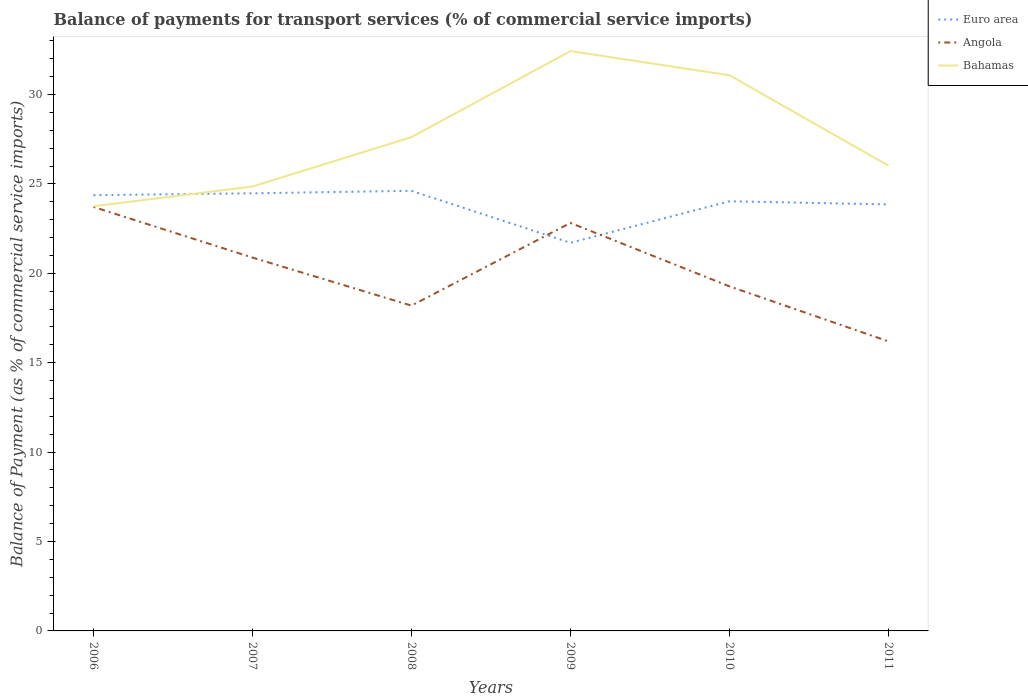How many different coloured lines are there?
Offer a very short reply. 3. Across all years, what is the maximum balance of payments for transport services in Bahamas?
Your response must be concise. 23.75. In which year was the balance of payments for transport services in Euro area maximum?
Provide a succinct answer. 2009. What is the total balance of payments for transport services in Angola in the graph?
Offer a terse response. 2.83. What is the difference between the highest and the second highest balance of payments for transport services in Bahamas?
Make the answer very short. 8.68. What is the difference between the highest and the lowest balance of payments for transport services in Bahamas?
Keep it short and to the point. 2. Is the balance of payments for transport services in Angola strictly greater than the balance of payments for transport services in Euro area over the years?
Your response must be concise. No. What is the difference between two consecutive major ticks on the Y-axis?
Your response must be concise. 5. Are the values on the major ticks of Y-axis written in scientific E-notation?
Make the answer very short. No. Does the graph contain grids?
Ensure brevity in your answer.  No. What is the title of the graph?
Provide a short and direct response. Balance of payments for transport services (% of commercial service imports). What is the label or title of the Y-axis?
Ensure brevity in your answer.  Balance of Payment (as % of commercial service imports). What is the Balance of Payment (as % of commercial service imports) in Euro area in 2006?
Make the answer very short. 24.37. What is the Balance of Payment (as % of commercial service imports) of Angola in 2006?
Your response must be concise. 23.71. What is the Balance of Payment (as % of commercial service imports) in Bahamas in 2006?
Your response must be concise. 23.75. What is the Balance of Payment (as % of commercial service imports) of Euro area in 2007?
Your answer should be compact. 24.47. What is the Balance of Payment (as % of commercial service imports) in Angola in 2007?
Provide a succinct answer. 20.88. What is the Balance of Payment (as % of commercial service imports) of Bahamas in 2007?
Give a very brief answer. 24.85. What is the Balance of Payment (as % of commercial service imports) of Euro area in 2008?
Keep it short and to the point. 24.61. What is the Balance of Payment (as % of commercial service imports) of Angola in 2008?
Your answer should be very brief. 18.19. What is the Balance of Payment (as % of commercial service imports) in Bahamas in 2008?
Provide a succinct answer. 27.62. What is the Balance of Payment (as % of commercial service imports) of Euro area in 2009?
Provide a succinct answer. 21.71. What is the Balance of Payment (as % of commercial service imports) in Angola in 2009?
Provide a short and direct response. 22.82. What is the Balance of Payment (as % of commercial service imports) in Bahamas in 2009?
Make the answer very short. 32.43. What is the Balance of Payment (as % of commercial service imports) of Euro area in 2010?
Ensure brevity in your answer.  24.03. What is the Balance of Payment (as % of commercial service imports) in Angola in 2010?
Your answer should be very brief. 19.27. What is the Balance of Payment (as % of commercial service imports) in Bahamas in 2010?
Offer a terse response. 31.08. What is the Balance of Payment (as % of commercial service imports) in Euro area in 2011?
Give a very brief answer. 23.85. What is the Balance of Payment (as % of commercial service imports) of Angola in 2011?
Your response must be concise. 16.19. What is the Balance of Payment (as % of commercial service imports) in Bahamas in 2011?
Ensure brevity in your answer.  26.02. Across all years, what is the maximum Balance of Payment (as % of commercial service imports) of Euro area?
Keep it short and to the point. 24.61. Across all years, what is the maximum Balance of Payment (as % of commercial service imports) of Angola?
Offer a terse response. 23.71. Across all years, what is the maximum Balance of Payment (as % of commercial service imports) of Bahamas?
Make the answer very short. 32.43. Across all years, what is the minimum Balance of Payment (as % of commercial service imports) of Euro area?
Your response must be concise. 21.71. Across all years, what is the minimum Balance of Payment (as % of commercial service imports) of Angola?
Ensure brevity in your answer.  16.19. Across all years, what is the minimum Balance of Payment (as % of commercial service imports) of Bahamas?
Your answer should be very brief. 23.75. What is the total Balance of Payment (as % of commercial service imports) of Euro area in the graph?
Your answer should be compact. 143.05. What is the total Balance of Payment (as % of commercial service imports) of Angola in the graph?
Provide a short and direct response. 121.07. What is the total Balance of Payment (as % of commercial service imports) of Bahamas in the graph?
Your answer should be very brief. 165.75. What is the difference between the Balance of Payment (as % of commercial service imports) in Euro area in 2006 and that in 2007?
Offer a very short reply. -0.1. What is the difference between the Balance of Payment (as % of commercial service imports) in Angola in 2006 and that in 2007?
Your response must be concise. 2.83. What is the difference between the Balance of Payment (as % of commercial service imports) in Bahamas in 2006 and that in 2007?
Provide a short and direct response. -1.1. What is the difference between the Balance of Payment (as % of commercial service imports) in Euro area in 2006 and that in 2008?
Offer a very short reply. -0.24. What is the difference between the Balance of Payment (as % of commercial service imports) of Angola in 2006 and that in 2008?
Offer a very short reply. 5.52. What is the difference between the Balance of Payment (as % of commercial service imports) of Bahamas in 2006 and that in 2008?
Your answer should be very brief. -3.87. What is the difference between the Balance of Payment (as % of commercial service imports) of Euro area in 2006 and that in 2009?
Your response must be concise. 2.67. What is the difference between the Balance of Payment (as % of commercial service imports) of Angola in 2006 and that in 2009?
Your answer should be very brief. 0.89. What is the difference between the Balance of Payment (as % of commercial service imports) in Bahamas in 2006 and that in 2009?
Your answer should be compact. -8.68. What is the difference between the Balance of Payment (as % of commercial service imports) of Euro area in 2006 and that in 2010?
Your answer should be very brief. 0.34. What is the difference between the Balance of Payment (as % of commercial service imports) of Angola in 2006 and that in 2010?
Provide a short and direct response. 4.44. What is the difference between the Balance of Payment (as % of commercial service imports) of Bahamas in 2006 and that in 2010?
Keep it short and to the point. -7.33. What is the difference between the Balance of Payment (as % of commercial service imports) of Euro area in 2006 and that in 2011?
Your answer should be very brief. 0.52. What is the difference between the Balance of Payment (as % of commercial service imports) in Angola in 2006 and that in 2011?
Make the answer very short. 7.52. What is the difference between the Balance of Payment (as % of commercial service imports) of Bahamas in 2006 and that in 2011?
Ensure brevity in your answer.  -2.27. What is the difference between the Balance of Payment (as % of commercial service imports) of Euro area in 2007 and that in 2008?
Make the answer very short. -0.14. What is the difference between the Balance of Payment (as % of commercial service imports) in Angola in 2007 and that in 2008?
Your answer should be very brief. 2.69. What is the difference between the Balance of Payment (as % of commercial service imports) of Bahamas in 2007 and that in 2008?
Your answer should be very brief. -2.76. What is the difference between the Balance of Payment (as % of commercial service imports) in Euro area in 2007 and that in 2009?
Your answer should be very brief. 2.77. What is the difference between the Balance of Payment (as % of commercial service imports) of Angola in 2007 and that in 2009?
Your answer should be compact. -1.94. What is the difference between the Balance of Payment (as % of commercial service imports) of Bahamas in 2007 and that in 2009?
Give a very brief answer. -7.57. What is the difference between the Balance of Payment (as % of commercial service imports) of Euro area in 2007 and that in 2010?
Give a very brief answer. 0.45. What is the difference between the Balance of Payment (as % of commercial service imports) in Angola in 2007 and that in 2010?
Ensure brevity in your answer.  1.61. What is the difference between the Balance of Payment (as % of commercial service imports) of Bahamas in 2007 and that in 2010?
Your answer should be very brief. -6.22. What is the difference between the Balance of Payment (as % of commercial service imports) in Euro area in 2007 and that in 2011?
Your answer should be very brief. 0.62. What is the difference between the Balance of Payment (as % of commercial service imports) in Angola in 2007 and that in 2011?
Keep it short and to the point. 4.69. What is the difference between the Balance of Payment (as % of commercial service imports) of Bahamas in 2007 and that in 2011?
Your response must be concise. -1.17. What is the difference between the Balance of Payment (as % of commercial service imports) of Euro area in 2008 and that in 2009?
Your answer should be compact. 2.91. What is the difference between the Balance of Payment (as % of commercial service imports) of Angola in 2008 and that in 2009?
Provide a short and direct response. -4.63. What is the difference between the Balance of Payment (as % of commercial service imports) in Bahamas in 2008 and that in 2009?
Your response must be concise. -4.81. What is the difference between the Balance of Payment (as % of commercial service imports) in Euro area in 2008 and that in 2010?
Offer a terse response. 0.58. What is the difference between the Balance of Payment (as % of commercial service imports) of Angola in 2008 and that in 2010?
Ensure brevity in your answer.  -1.08. What is the difference between the Balance of Payment (as % of commercial service imports) of Bahamas in 2008 and that in 2010?
Make the answer very short. -3.46. What is the difference between the Balance of Payment (as % of commercial service imports) in Euro area in 2008 and that in 2011?
Ensure brevity in your answer.  0.76. What is the difference between the Balance of Payment (as % of commercial service imports) of Angola in 2008 and that in 2011?
Ensure brevity in your answer.  2. What is the difference between the Balance of Payment (as % of commercial service imports) in Bahamas in 2008 and that in 2011?
Your answer should be very brief. 1.6. What is the difference between the Balance of Payment (as % of commercial service imports) of Euro area in 2009 and that in 2010?
Provide a succinct answer. -2.32. What is the difference between the Balance of Payment (as % of commercial service imports) of Angola in 2009 and that in 2010?
Offer a terse response. 3.55. What is the difference between the Balance of Payment (as % of commercial service imports) of Bahamas in 2009 and that in 2010?
Your answer should be very brief. 1.35. What is the difference between the Balance of Payment (as % of commercial service imports) in Euro area in 2009 and that in 2011?
Make the answer very short. -2.15. What is the difference between the Balance of Payment (as % of commercial service imports) in Angola in 2009 and that in 2011?
Provide a succinct answer. 6.63. What is the difference between the Balance of Payment (as % of commercial service imports) in Bahamas in 2009 and that in 2011?
Provide a succinct answer. 6.41. What is the difference between the Balance of Payment (as % of commercial service imports) of Euro area in 2010 and that in 2011?
Your answer should be very brief. 0.18. What is the difference between the Balance of Payment (as % of commercial service imports) in Angola in 2010 and that in 2011?
Offer a very short reply. 3.08. What is the difference between the Balance of Payment (as % of commercial service imports) in Bahamas in 2010 and that in 2011?
Provide a short and direct response. 5.06. What is the difference between the Balance of Payment (as % of commercial service imports) in Euro area in 2006 and the Balance of Payment (as % of commercial service imports) in Angola in 2007?
Ensure brevity in your answer.  3.49. What is the difference between the Balance of Payment (as % of commercial service imports) in Euro area in 2006 and the Balance of Payment (as % of commercial service imports) in Bahamas in 2007?
Offer a very short reply. -0.48. What is the difference between the Balance of Payment (as % of commercial service imports) in Angola in 2006 and the Balance of Payment (as % of commercial service imports) in Bahamas in 2007?
Ensure brevity in your answer.  -1.14. What is the difference between the Balance of Payment (as % of commercial service imports) of Euro area in 2006 and the Balance of Payment (as % of commercial service imports) of Angola in 2008?
Your response must be concise. 6.18. What is the difference between the Balance of Payment (as % of commercial service imports) of Euro area in 2006 and the Balance of Payment (as % of commercial service imports) of Bahamas in 2008?
Your response must be concise. -3.25. What is the difference between the Balance of Payment (as % of commercial service imports) in Angola in 2006 and the Balance of Payment (as % of commercial service imports) in Bahamas in 2008?
Make the answer very short. -3.9. What is the difference between the Balance of Payment (as % of commercial service imports) of Euro area in 2006 and the Balance of Payment (as % of commercial service imports) of Angola in 2009?
Make the answer very short. 1.55. What is the difference between the Balance of Payment (as % of commercial service imports) of Euro area in 2006 and the Balance of Payment (as % of commercial service imports) of Bahamas in 2009?
Make the answer very short. -8.06. What is the difference between the Balance of Payment (as % of commercial service imports) of Angola in 2006 and the Balance of Payment (as % of commercial service imports) of Bahamas in 2009?
Ensure brevity in your answer.  -8.71. What is the difference between the Balance of Payment (as % of commercial service imports) of Euro area in 2006 and the Balance of Payment (as % of commercial service imports) of Angola in 2010?
Offer a terse response. 5.1. What is the difference between the Balance of Payment (as % of commercial service imports) of Euro area in 2006 and the Balance of Payment (as % of commercial service imports) of Bahamas in 2010?
Ensure brevity in your answer.  -6.71. What is the difference between the Balance of Payment (as % of commercial service imports) in Angola in 2006 and the Balance of Payment (as % of commercial service imports) in Bahamas in 2010?
Offer a very short reply. -7.36. What is the difference between the Balance of Payment (as % of commercial service imports) in Euro area in 2006 and the Balance of Payment (as % of commercial service imports) in Angola in 2011?
Ensure brevity in your answer.  8.18. What is the difference between the Balance of Payment (as % of commercial service imports) of Euro area in 2006 and the Balance of Payment (as % of commercial service imports) of Bahamas in 2011?
Your answer should be very brief. -1.65. What is the difference between the Balance of Payment (as % of commercial service imports) of Angola in 2006 and the Balance of Payment (as % of commercial service imports) of Bahamas in 2011?
Keep it short and to the point. -2.31. What is the difference between the Balance of Payment (as % of commercial service imports) of Euro area in 2007 and the Balance of Payment (as % of commercial service imports) of Angola in 2008?
Your response must be concise. 6.28. What is the difference between the Balance of Payment (as % of commercial service imports) in Euro area in 2007 and the Balance of Payment (as % of commercial service imports) in Bahamas in 2008?
Make the answer very short. -3.14. What is the difference between the Balance of Payment (as % of commercial service imports) in Angola in 2007 and the Balance of Payment (as % of commercial service imports) in Bahamas in 2008?
Provide a short and direct response. -6.74. What is the difference between the Balance of Payment (as % of commercial service imports) of Euro area in 2007 and the Balance of Payment (as % of commercial service imports) of Angola in 2009?
Provide a short and direct response. 1.66. What is the difference between the Balance of Payment (as % of commercial service imports) in Euro area in 2007 and the Balance of Payment (as % of commercial service imports) in Bahamas in 2009?
Make the answer very short. -7.95. What is the difference between the Balance of Payment (as % of commercial service imports) in Angola in 2007 and the Balance of Payment (as % of commercial service imports) in Bahamas in 2009?
Your answer should be compact. -11.55. What is the difference between the Balance of Payment (as % of commercial service imports) in Euro area in 2007 and the Balance of Payment (as % of commercial service imports) in Angola in 2010?
Keep it short and to the point. 5.2. What is the difference between the Balance of Payment (as % of commercial service imports) of Euro area in 2007 and the Balance of Payment (as % of commercial service imports) of Bahamas in 2010?
Offer a terse response. -6.6. What is the difference between the Balance of Payment (as % of commercial service imports) in Angola in 2007 and the Balance of Payment (as % of commercial service imports) in Bahamas in 2010?
Keep it short and to the point. -10.2. What is the difference between the Balance of Payment (as % of commercial service imports) of Euro area in 2007 and the Balance of Payment (as % of commercial service imports) of Angola in 2011?
Your answer should be very brief. 8.28. What is the difference between the Balance of Payment (as % of commercial service imports) of Euro area in 2007 and the Balance of Payment (as % of commercial service imports) of Bahamas in 2011?
Give a very brief answer. -1.55. What is the difference between the Balance of Payment (as % of commercial service imports) of Angola in 2007 and the Balance of Payment (as % of commercial service imports) of Bahamas in 2011?
Your response must be concise. -5.14. What is the difference between the Balance of Payment (as % of commercial service imports) in Euro area in 2008 and the Balance of Payment (as % of commercial service imports) in Angola in 2009?
Your response must be concise. 1.79. What is the difference between the Balance of Payment (as % of commercial service imports) of Euro area in 2008 and the Balance of Payment (as % of commercial service imports) of Bahamas in 2009?
Make the answer very short. -7.81. What is the difference between the Balance of Payment (as % of commercial service imports) in Angola in 2008 and the Balance of Payment (as % of commercial service imports) in Bahamas in 2009?
Offer a terse response. -14.23. What is the difference between the Balance of Payment (as % of commercial service imports) of Euro area in 2008 and the Balance of Payment (as % of commercial service imports) of Angola in 2010?
Ensure brevity in your answer.  5.34. What is the difference between the Balance of Payment (as % of commercial service imports) of Euro area in 2008 and the Balance of Payment (as % of commercial service imports) of Bahamas in 2010?
Offer a terse response. -6.46. What is the difference between the Balance of Payment (as % of commercial service imports) in Angola in 2008 and the Balance of Payment (as % of commercial service imports) in Bahamas in 2010?
Your answer should be very brief. -12.88. What is the difference between the Balance of Payment (as % of commercial service imports) of Euro area in 2008 and the Balance of Payment (as % of commercial service imports) of Angola in 2011?
Your answer should be very brief. 8.42. What is the difference between the Balance of Payment (as % of commercial service imports) in Euro area in 2008 and the Balance of Payment (as % of commercial service imports) in Bahamas in 2011?
Provide a short and direct response. -1.41. What is the difference between the Balance of Payment (as % of commercial service imports) of Angola in 2008 and the Balance of Payment (as % of commercial service imports) of Bahamas in 2011?
Give a very brief answer. -7.83. What is the difference between the Balance of Payment (as % of commercial service imports) in Euro area in 2009 and the Balance of Payment (as % of commercial service imports) in Angola in 2010?
Your answer should be very brief. 2.44. What is the difference between the Balance of Payment (as % of commercial service imports) in Euro area in 2009 and the Balance of Payment (as % of commercial service imports) in Bahamas in 2010?
Offer a very short reply. -9.37. What is the difference between the Balance of Payment (as % of commercial service imports) of Angola in 2009 and the Balance of Payment (as % of commercial service imports) of Bahamas in 2010?
Offer a terse response. -8.26. What is the difference between the Balance of Payment (as % of commercial service imports) of Euro area in 2009 and the Balance of Payment (as % of commercial service imports) of Angola in 2011?
Give a very brief answer. 5.51. What is the difference between the Balance of Payment (as % of commercial service imports) of Euro area in 2009 and the Balance of Payment (as % of commercial service imports) of Bahamas in 2011?
Make the answer very short. -4.31. What is the difference between the Balance of Payment (as % of commercial service imports) of Angola in 2009 and the Balance of Payment (as % of commercial service imports) of Bahamas in 2011?
Provide a succinct answer. -3.2. What is the difference between the Balance of Payment (as % of commercial service imports) in Euro area in 2010 and the Balance of Payment (as % of commercial service imports) in Angola in 2011?
Your response must be concise. 7.84. What is the difference between the Balance of Payment (as % of commercial service imports) in Euro area in 2010 and the Balance of Payment (as % of commercial service imports) in Bahamas in 2011?
Offer a very short reply. -1.99. What is the difference between the Balance of Payment (as % of commercial service imports) in Angola in 2010 and the Balance of Payment (as % of commercial service imports) in Bahamas in 2011?
Your answer should be very brief. -6.75. What is the average Balance of Payment (as % of commercial service imports) of Euro area per year?
Ensure brevity in your answer.  23.84. What is the average Balance of Payment (as % of commercial service imports) in Angola per year?
Make the answer very short. 20.18. What is the average Balance of Payment (as % of commercial service imports) in Bahamas per year?
Ensure brevity in your answer.  27.62. In the year 2006, what is the difference between the Balance of Payment (as % of commercial service imports) in Euro area and Balance of Payment (as % of commercial service imports) in Angola?
Provide a succinct answer. 0.66. In the year 2006, what is the difference between the Balance of Payment (as % of commercial service imports) of Euro area and Balance of Payment (as % of commercial service imports) of Bahamas?
Your response must be concise. 0.62. In the year 2006, what is the difference between the Balance of Payment (as % of commercial service imports) in Angola and Balance of Payment (as % of commercial service imports) in Bahamas?
Provide a succinct answer. -0.04. In the year 2007, what is the difference between the Balance of Payment (as % of commercial service imports) in Euro area and Balance of Payment (as % of commercial service imports) in Angola?
Keep it short and to the point. 3.6. In the year 2007, what is the difference between the Balance of Payment (as % of commercial service imports) in Euro area and Balance of Payment (as % of commercial service imports) in Bahamas?
Your response must be concise. -0.38. In the year 2007, what is the difference between the Balance of Payment (as % of commercial service imports) of Angola and Balance of Payment (as % of commercial service imports) of Bahamas?
Keep it short and to the point. -3.97. In the year 2008, what is the difference between the Balance of Payment (as % of commercial service imports) in Euro area and Balance of Payment (as % of commercial service imports) in Angola?
Your answer should be very brief. 6.42. In the year 2008, what is the difference between the Balance of Payment (as % of commercial service imports) of Euro area and Balance of Payment (as % of commercial service imports) of Bahamas?
Your answer should be compact. -3. In the year 2008, what is the difference between the Balance of Payment (as % of commercial service imports) in Angola and Balance of Payment (as % of commercial service imports) in Bahamas?
Give a very brief answer. -9.42. In the year 2009, what is the difference between the Balance of Payment (as % of commercial service imports) in Euro area and Balance of Payment (as % of commercial service imports) in Angola?
Your answer should be compact. -1.11. In the year 2009, what is the difference between the Balance of Payment (as % of commercial service imports) of Euro area and Balance of Payment (as % of commercial service imports) of Bahamas?
Offer a very short reply. -10.72. In the year 2009, what is the difference between the Balance of Payment (as % of commercial service imports) in Angola and Balance of Payment (as % of commercial service imports) in Bahamas?
Make the answer very short. -9.61. In the year 2010, what is the difference between the Balance of Payment (as % of commercial service imports) in Euro area and Balance of Payment (as % of commercial service imports) in Angola?
Give a very brief answer. 4.76. In the year 2010, what is the difference between the Balance of Payment (as % of commercial service imports) of Euro area and Balance of Payment (as % of commercial service imports) of Bahamas?
Provide a succinct answer. -7.05. In the year 2010, what is the difference between the Balance of Payment (as % of commercial service imports) of Angola and Balance of Payment (as % of commercial service imports) of Bahamas?
Offer a very short reply. -11.81. In the year 2011, what is the difference between the Balance of Payment (as % of commercial service imports) of Euro area and Balance of Payment (as % of commercial service imports) of Angola?
Provide a succinct answer. 7.66. In the year 2011, what is the difference between the Balance of Payment (as % of commercial service imports) of Euro area and Balance of Payment (as % of commercial service imports) of Bahamas?
Your response must be concise. -2.17. In the year 2011, what is the difference between the Balance of Payment (as % of commercial service imports) in Angola and Balance of Payment (as % of commercial service imports) in Bahamas?
Provide a succinct answer. -9.83. What is the ratio of the Balance of Payment (as % of commercial service imports) of Euro area in 2006 to that in 2007?
Provide a succinct answer. 1. What is the ratio of the Balance of Payment (as % of commercial service imports) in Angola in 2006 to that in 2007?
Give a very brief answer. 1.14. What is the ratio of the Balance of Payment (as % of commercial service imports) in Bahamas in 2006 to that in 2007?
Give a very brief answer. 0.96. What is the ratio of the Balance of Payment (as % of commercial service imports) of Angola in 2006 to that in 2008?
Ensure brevity in your answer.  1.3. What is the ratio of the Balance of Payment (as % of commercial service imports) in Bahamas in 2006 to that in 2008?
Ensure brevity in your answer.  0.86. What is the ratio of the Balance of Payment (as % of commercial service imports) in Euro area in 2006 to that in 2009?
Ensure brevity in your answer.  1.12. What is the ratio of the Balance of Payment (as % of commercial service imports) of Angola in 2006 to that in 2009?
Provide a succinct answer. 1.04. What is the ratio of the Balance of Payment (as % of commercial service imports) in Bahamas in 2006 to that in 2009?
Your response must be concise. 0.73. What is the ratio of the Balance of Payment (as % of commercial service imports) of Euro area in 2006 to that in 2010?
Provide a succinct answer. 1.01. What is the ratio of the Balance of Payment (as % of commercial service imports) in Angola in 2006 to that in 2010?
Ensure brevity in your answer.  1.23. What is the ratio of the Balance of Payment (as % of commercial service imports) in Bahamas in 2006 to that in 2010?
Provide a short and direct response. 0.76. What is the ratio of the Balance of Payment (as % of commercial service imports) in Euro area in 2006 to that in 2011?
Give a very brief answer. 1.02. What is the ratio of the Balance of Payment (as % of commercial service imports) of Angola in 2006 to that in 2011?
Make the answer very short. 1.46. What is the ratio of the Balance of Payment (as % of commercial service imports) of Bahamas in 2006 to that in 2011?
Make the answer very short. 0.91. What is the ratio of the Balance of Payment (as % of commercial service imports) in Angola in 2007 to that in 2008?
Your response must be concise. 1.15. What is the ratio of the Balance of Payment (as % of commercial service imports) in Bahamas in 2007 to that in 2008?
Keep it short and to the point. 0.9. What is the ratio of the Balance of Payment (as % of commercial service imports) in Euro area in 2007 to that in 2009?
Your answer should be compact. 1.13. What is the ratio of the Balance of Payment (as % of commercial service imports) in Angola in 2007 to that in 2009?
Keep it short and to the point. 0.92. What is the ratio of the Balance of Payment (as % of commercial service imports) in Bahamas in 2007 to that in 2009?
Keep it short and to the point. 0.77. What is the ratio of the Balance of Payment (as % of commercial service imports) of Euro area in 2007 to that in 2010?
Provide a short and direct response. 1.02. What is the ratio of the Balance of Payment (as % of commercial service imports) in Angola in 2007 to that in 2010?
Make the answer very short. 1.08. What is the ratio of the Balance of Payment (as % of commercial service imports) in Bahamas in 2007 to that in 2010?
Your answer should be compact. 0.8. What is the ratio of the Balance of Payment (as % of commercial service imports) of Euro area in 2007 to that in 2011?
Provide a short and direct response. 1.03. What is the ratio of the Balance of Payment (as % of commercial service imports) of Angola in 2007 to that in 2011?
Keep it short and to the point. 1.29. What is the ratio of the Balance of Payment (as % of commercial service imports) of Bahamas in 2007 to that in 2011?
Give a very brief answer. 0.96. What is the ratio of the Balance of Payment (as % of commercial service imports) of Euro area in 2008 to that in 2009?
Offer a terse response. 1.13. What is the ratio of the Balance of Payment (as % of commercial service imports) in Angola in 2008 to that in 2009?
Make the answer very short. 0.8. What is the ratio of the Balance of Payment (as % of commercial service imports) of Bahamas in 2008 to that in 2009?
Offer a terse response. 0.85. What is the ratio of the Balance of Payment (as % of commercial service imports) of Euro area in 2008 to that in 2010?
Provide a short and direct response. 1.02. What is the ratio of the Balance of Payment (as % of commercial service imports) in Angola in 2008 to that in 2010?
Your response must be concise. 0.94. What is the ratio of the Balance of Payment (as % of commercial service imports) of Bahamas in 2008 to that in 2010?
Your response must be concise. 0.89. What is the ratio of the Balance of Payment (as % of commercial service imports) in Euro area in 2008 to that in 2011?
Ensure brevity in your answer.  1.03. What is the ratio of the Balance of Payment (as % of commercial service imports) of Angola in 2008 to that in 2011?
Offer a very short reply. 1.12. What is the ratio of the Balance of Payment (as % of commercial service imports) in Bahamas in 2008 to that in 2011?
Make the answer very short. 1.06. What is the ratio of the Balance of Payment (as % of commercial service imports) in Euro area in 2009 to that in 2010?
Provide a succinct answer. 0.9. What is the ratio of the Balance of Payment (as % of commercial service imports) of Angola in 2009 to that in 2010?
Your response must be concise. 1.18. What is the ratio of the Balance of Payment (as % of commercial service imports) of Bahamas in 2009 to that in 2010?
Provide a succinct answer. 1.04. What is the ratio of the Balance of Payment (as % of commercial service imports) of Euro area in 2009 to that in 2011?
Your response must be concise. 0.91. What is the ratio of the Balance of Payment (as % of commercial service imports) of Angola in 2009 to that in 2011?
Keep it short and to the point. 1.41. What is the ratio of the Balance of Payment (as % of commercial service imports) in Bahamas in 2009 to that in 2011?
Ensure brevity in your answer.  1.25. What is the ratio of the Balance of Payment (as % of commercial service imports) of Euro area in 2010 to that in 2011?
Your answer should be very brief. 1.01. What is the ratio of the Balance of Payment (as % of commercial service imports) in Angola in 2010 to that in 2011?
Offer a terse response. 1.19. What is the ratio of the Balance of Payment (as % of commercial service imports) of Bahamas in 2010 to that in 2011?
Keep it short and to the point. 1.19. What is the difference between the highest and the second highest Balance of Payment (as % of commercial service imports) in Euro area?
Make the answer very short. 0.14. What is the difference between the highest and the second highest Balance of Payment (as % of commercial service imports) of Angola?
Ensure brevity in your answer.  0.89. What is the difference between the highest and the second highest Balance of Payment (as % of commercial service imports) of Bahamas?
Your answer should be compact. 1.35. What is the difference between the highest and the lowest Balance of Payment (as % of commercial service imports) of Euro area?
Offer a terse response. 2.91. What is the difference between the highest and the lowest Balance of Payment (as % of commercial service imports) of Angola?
Give a very brief answer. 7.52. What is the difference between the highest and the lowest Balance of Payment (as % of commercial service imports) in Bahamas?
Offer a terse response. 8.68. 